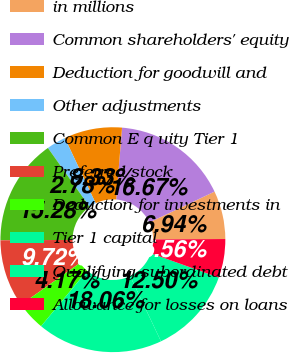Convert chart. <chart><loc_0><loc_0><loc_500><loc_500><pie_chart><fcel>in millions<fcel>Common shareholders' equity<fcel>Deduction for goodwill and<fcel>Other adjustments<fcel>Common E q uity Tier 1<fcel>Preferred stock<fcel>Deduction for investments in<fcel>Tier 1 capital<fcel>Qualifying subordinated debt<fcel>Allowance for losses on loans<nl><fcel>6.94%<fcel>16.67%<fcel>8.33%<fcel>2.78%<fcel>15.28%<fcel>9.72%<fcel>4.17%<fcel>18.06%<fcel>12.5%<fcel>5.56%<nl></chart> 